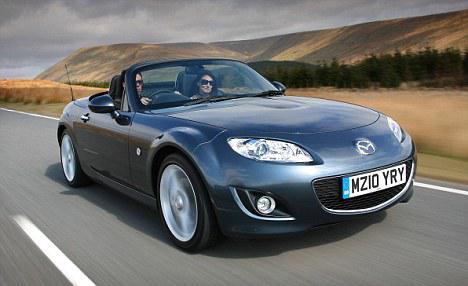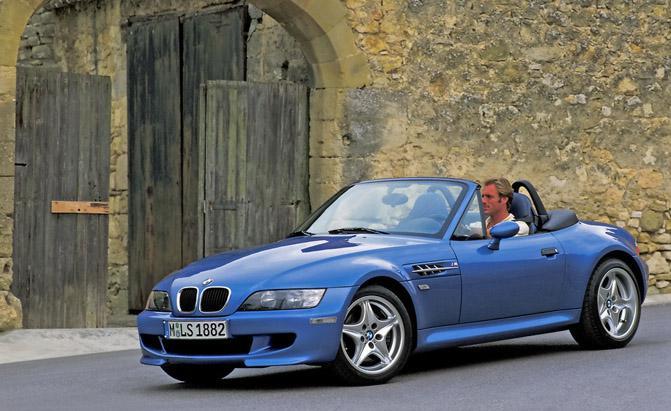The first image is the image on the left, the second image is the image on the right. Examine the images to the left and right. Is the description "there is a parked convertible on the road in fron't of a mountain background" accurate? Answer yes or no. No. The first image is the image on the left, the second image is the image on the right. For the images shown, is this caption "The car in the image on the left is parked in front of a building." true? Answer yes or no. No. 